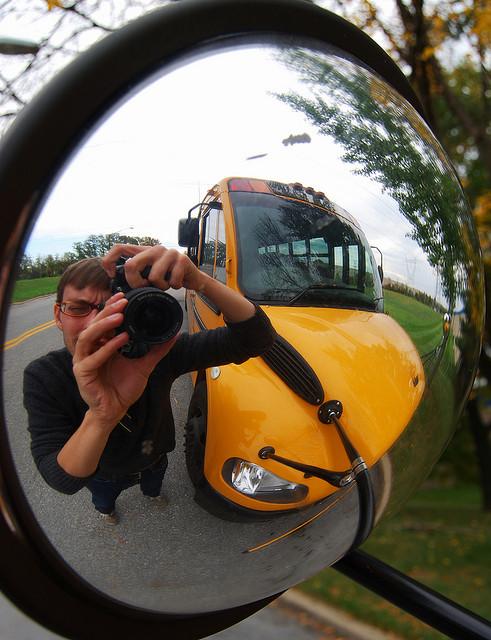What color is the bus?
Answer briefly. Yellow. Is the bus moving?
Concise answer only. No. Where are words written at?
Be succinct. Nowhere. What is the man holding?
Concise answer only. Camera. How many things are yellow?
Give a very brief answer. 1. When the picture was taken, was the camera pointing up?
Quick response, please. No. Why does this man look so distorted in the photo?
Answer briefly. Mirror. 